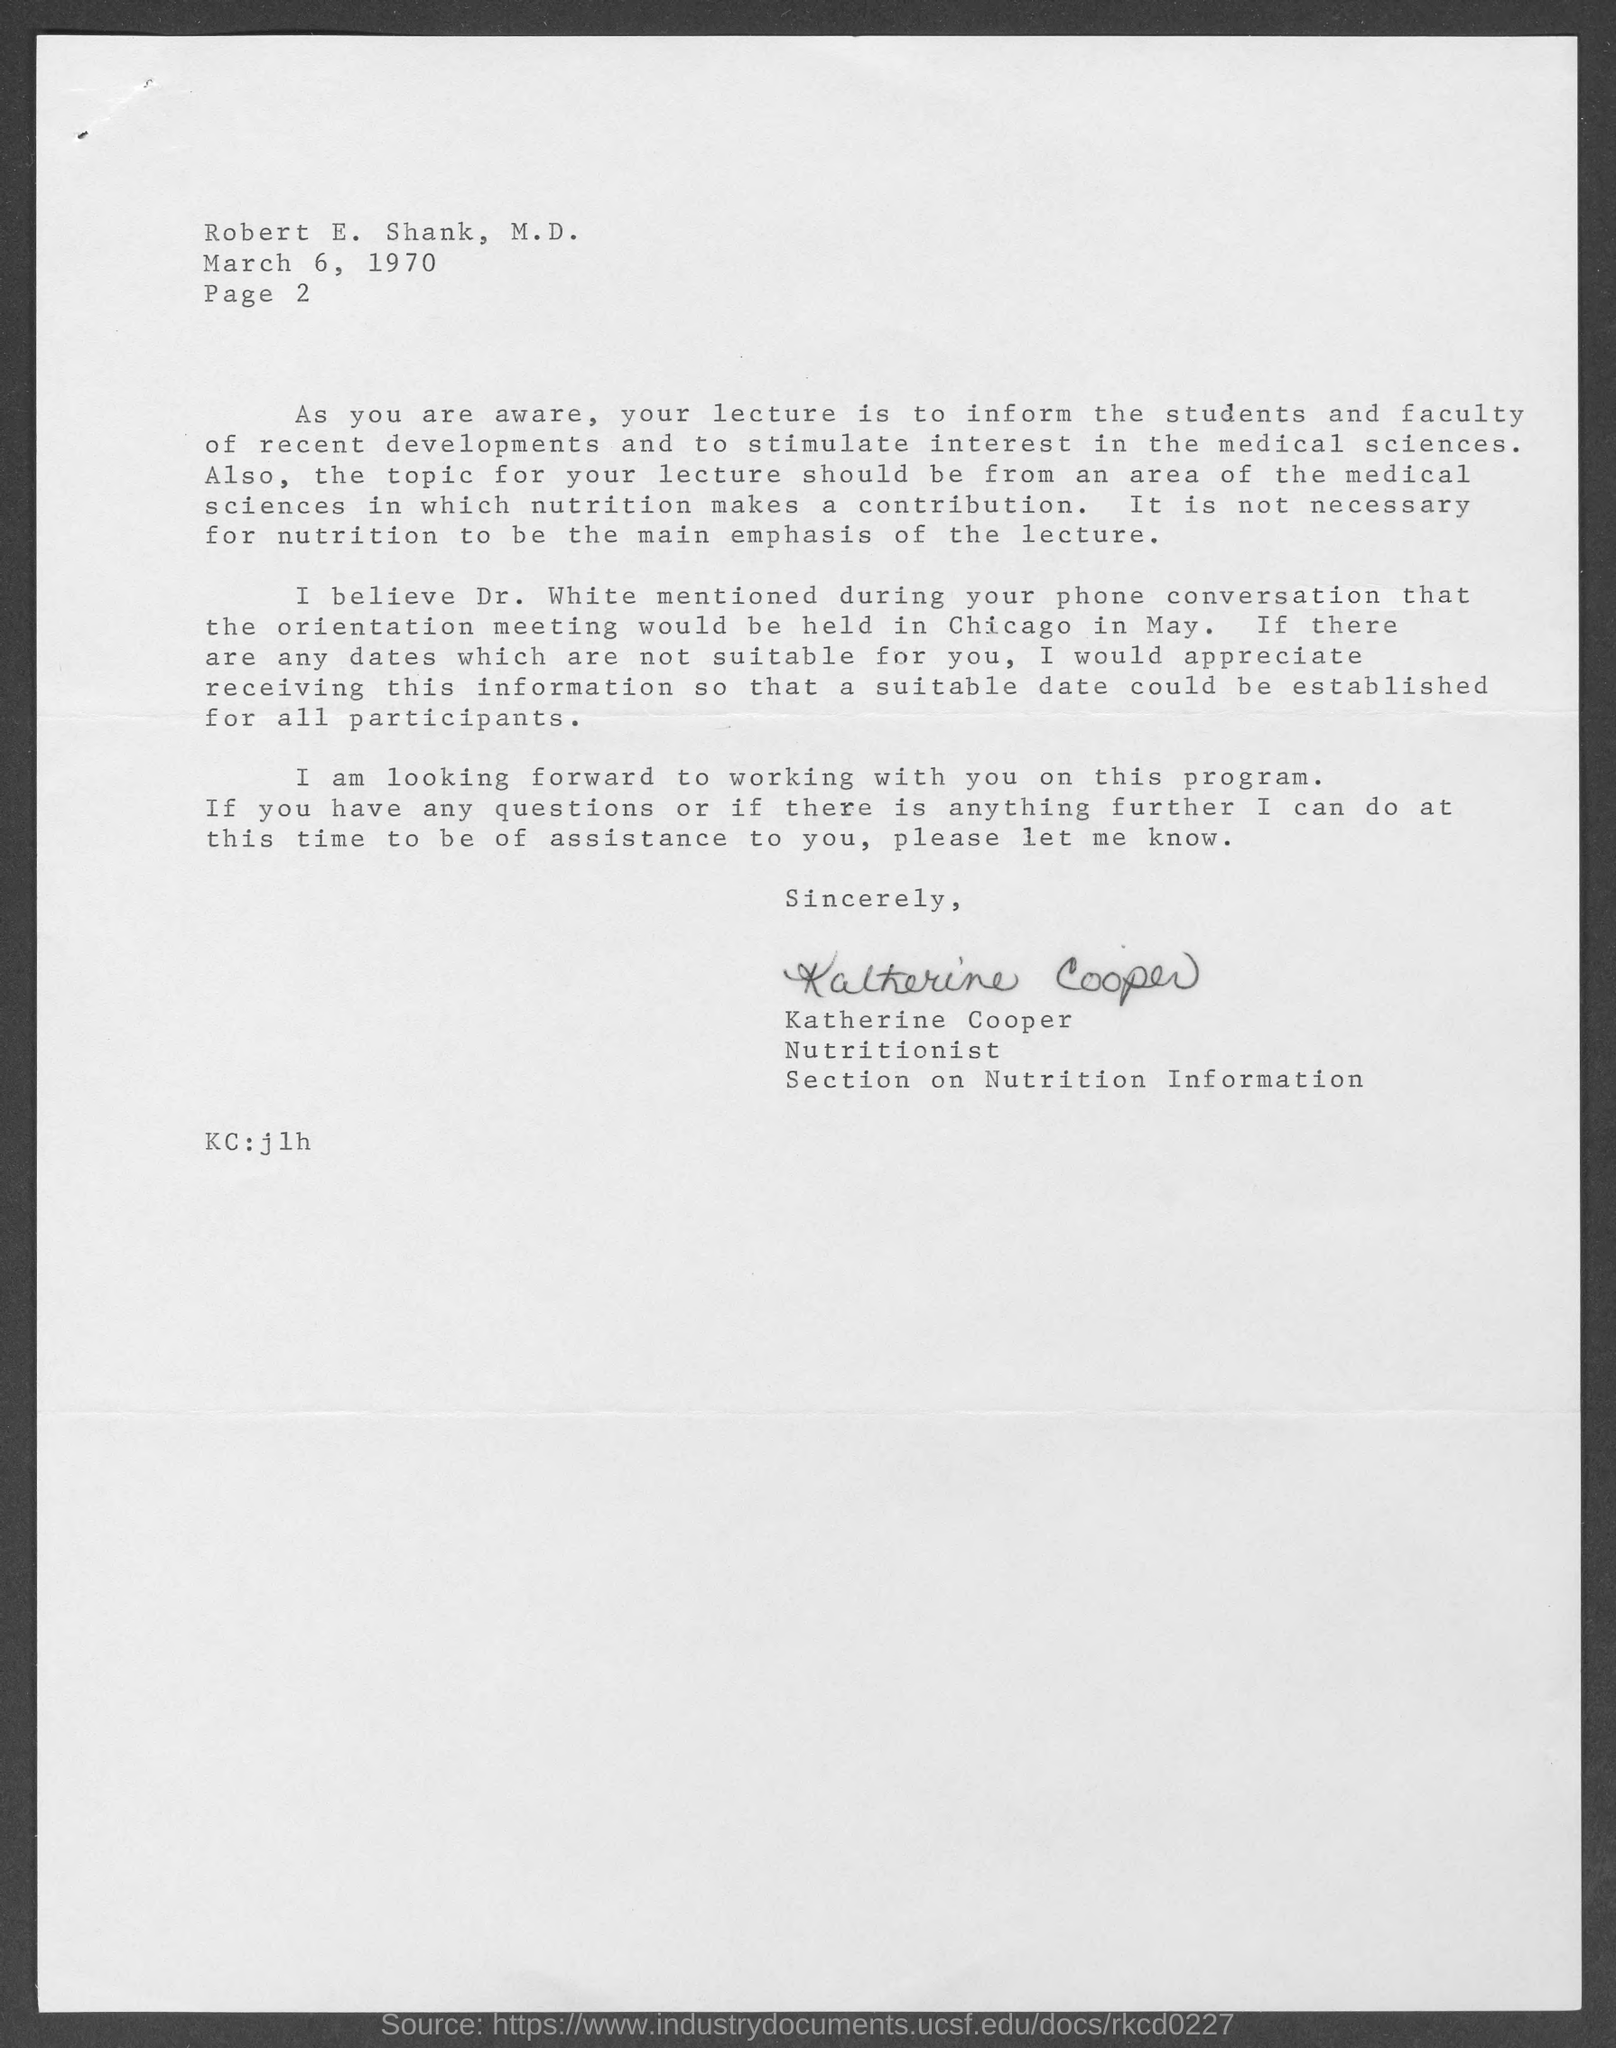What is the Page number written in the document ?
Provide a succinct answer. Page 2. Who is written this letter ?
Provide a short and direct response. Katherine Cooper. When is the memorandum dated on ?
Your answer should be compact. March 6, 1970. 